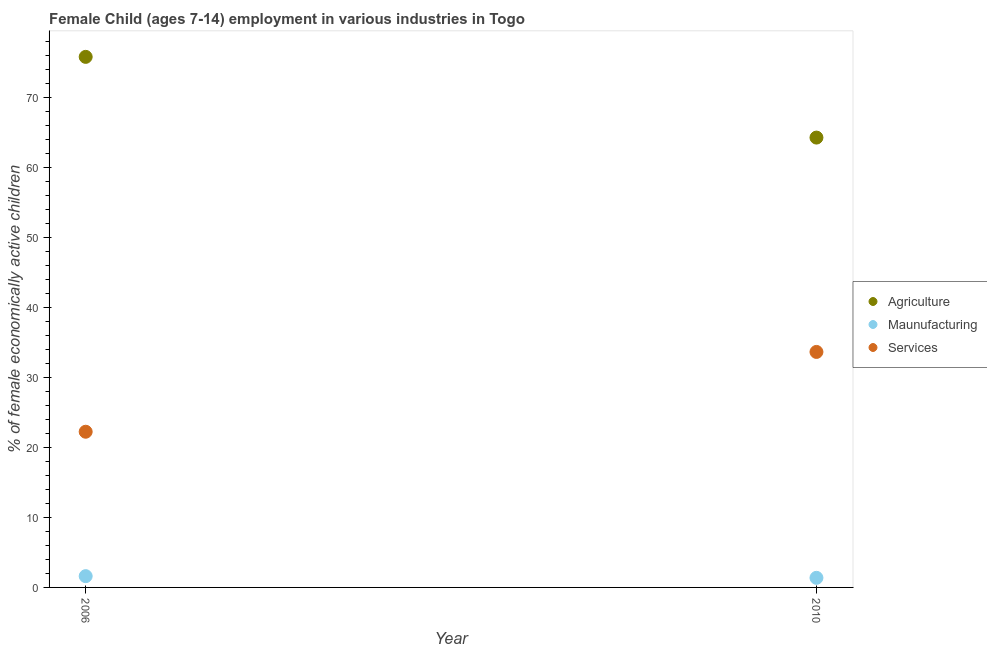What is the percentage of economically active children in services in 2010?
Your response must be concise. 33.64. Across all years, what is the maximum percentage of economically active children in manufacturing?
Your answer should be compact. 1.61. Across all years, what is the minimum percentage of economically active children in agriculture?
Provide a short and direct response. 64.26. In which year was the percentage of economically active children in agriculture minimum?
Ensure brevity in your answer.  2010. What is the total percentage of economically active children in services in the graph?
Make the answer very short. 55.88. What is the difference between the percentage of economically active children in services in 2006 and that in 2010?
Give a very brief answer. -11.4. What is the difference between the percentage of economically active children in manufacturing in 2010 and the percentage of economically active children in agriculture in 2006?
Offer a terse response. -74.42. What is the average percentage of economically active children in manufacturing per year?
Offer a terse response. 1.49. In the year 2006, what is the difference between the percentage of economically active children in agriculture and percentage of economically active children in manufacturing?
Your answer should be very brief. 74.18. What is the ratio of the percentage of economically active children in agriculture in 2006 to that in 2010?
Ensure brevity in your answer.  1.18. Is the percentage of economically active children in manufacturing in 2006 less than that in 2010?
Keep it short and to the point. No. In how many years, is the percentage of economically active children in agriculture greater than the average percentage of economically active children in agriculture taken over all years?
Ensure brevity in your answer.  1. How many years are there in the graph?
Provide a short and direct response. 2. Does the graph contain any zero values?
Make the answer very short. No. How many legend labels are there?
Your answer should be very brief. 3. What is the title of the graph?
Make the answer very short. Female Child (ages 7-14) employment in various industries in Togo. Does "Industrial Nitrous Oxide" appear as one of the legend labels in the graph?
Keep it short and to the point. No. What is the label or title of the Y-axis?
Your answer should be compact. % of female economically active children. What is the % of female economically active children in Agriculture in 2006?
Ensure brevity in your answer.  75.79. What is the % of female economically active children in Maunufacturing in 2006?
Make the answer very short. 1.61. What is the % of female economically active children of Services in 2006?
Offer a very short reply. 22.24. What is the % of female economically active children in Agriculture in 2010?
Ensure brevity in your answer.  64.26. What is the % of female economically active children of Maunufacturing in 2010?
Provide a succinct answer. 1.37. What is the % of female economically active children in Services in 2010?
Your response must be concise. 33.64. Across all years, what is the maximum % of female economically active children of Agriculture?
Offer a terse response. 75.79. Across all years, what is the maximum % of female economically active children of Maunufacturing?
Make the answer very short. 1.61. Across all years, what is the maximum % of female economically active children of Services?
Offer a very short reply. 33.64. Across all years, what is the minimum % of female economically active children of Agriculture?
Ensure brevity in your answer.  64.26. Across all years, what is the minimum % of female economically active children in Maunufacturing?
Offer a very short reply. 1.37. Across all years, what is the minimum % of female economically active children of Services?
Give a very brief answer. 22.24. What is the total % of female economically active children in Agriculture in the graph?
Provide a short and direct response. 140.05. What is the total % of female economically active children in Maunufacturing in the graph?
Offer a very short reply. 2.98. What is the total % of female economically active children of Services in the graph?
Offer a terse response. 55.88. What is the difference between the % of female economically active children of Agriculture in 2006 and that in 2010?
Make the answer very short. 11.53. What is the difference between the % of female economically active children of Maunufacturing in 2006 and that in 2010?
Keep it short and to the point. 0.24. What is the difference between the % of female economically active children of Agriculture in 2006 and the % of female economically active children of Maunufacturing in 2010?
Offer a very short reply. 74.42. What is the difference between the % of female economically active children in Agriculture in 2006 and the % of female economically active children in Services in 2010?
Your response must be concise. 42.15. What is the difference between the % of female economically active children in Maunufacturing in 2006 and the % of female economically active children in Services in 2010?
Make the answer very short. -32.03. What is the average % of female economically active children of Agriculture per year?
Your response must be concise. 70.03. What is the average % of female economically active children in Maunufacturing per year?
Your answer should be compact. 1.49. What is the average % of female economically active children in Services per year?
Make the answer very short. 27.94. In the year 2006, what is the difference between the % of female economically active children in Agriculture and % of female economically active children in Maunufacturing?
Provide a succinct answer. 74.18. In the year 2006, what is the difference between the % of female economically active children in Agriculture and % of female economically active children in Services?
Give a very brief answer. 53.55. In the year 2006, what is the difference between the % of female economically active children of Maunufacturing and % of female economically active children of Services?
Your response must be concise. -20.63. In the year 2010, what is the difference between the % of female economically active children of Agriculture and % of female economically active children of Maunufacturing?
Keep it short and to the point. 62.89. In the year 2010, what is the difference between the % of female economically active children of Agriculture and % of female economically active children of Services?
Offer a very short reply. 30.62. In the year 2010, what is the difference between the % of female economically active children of Maunufacturing and % of female economically active children of Services?
Your answer should be very brief. -32.27. What is the ratio of the % of female economically active children in Agriculture in 2006 to that in 2010?
Your response must be concise. 1.18. What is the ratio of the % of female economically active children in Maunufacturing in 2006 to that in 2010?
Give a very brief answer. 1.18. What is the ratio of the % of female economically active children in Services in 2006 to that in 2010?
Offer a very short reply. 0.66. What is the difference between the highest and the second highest % of female economically active children in Agriculture?
Provide a succinct answer. 11.53. What is the difference between the highest and the second highest % of female economically active children in Maunufacturing?
Make the answer very short. 0.24. What is the difference between the highest and the lowest % of female economically active children in Agriculture?
Keep it short and to the point. 11.53. What is the difference between the highest and the lowest % of female economically active children of Maunufacturing?
Ensure brevity in your answer.  0.24. 